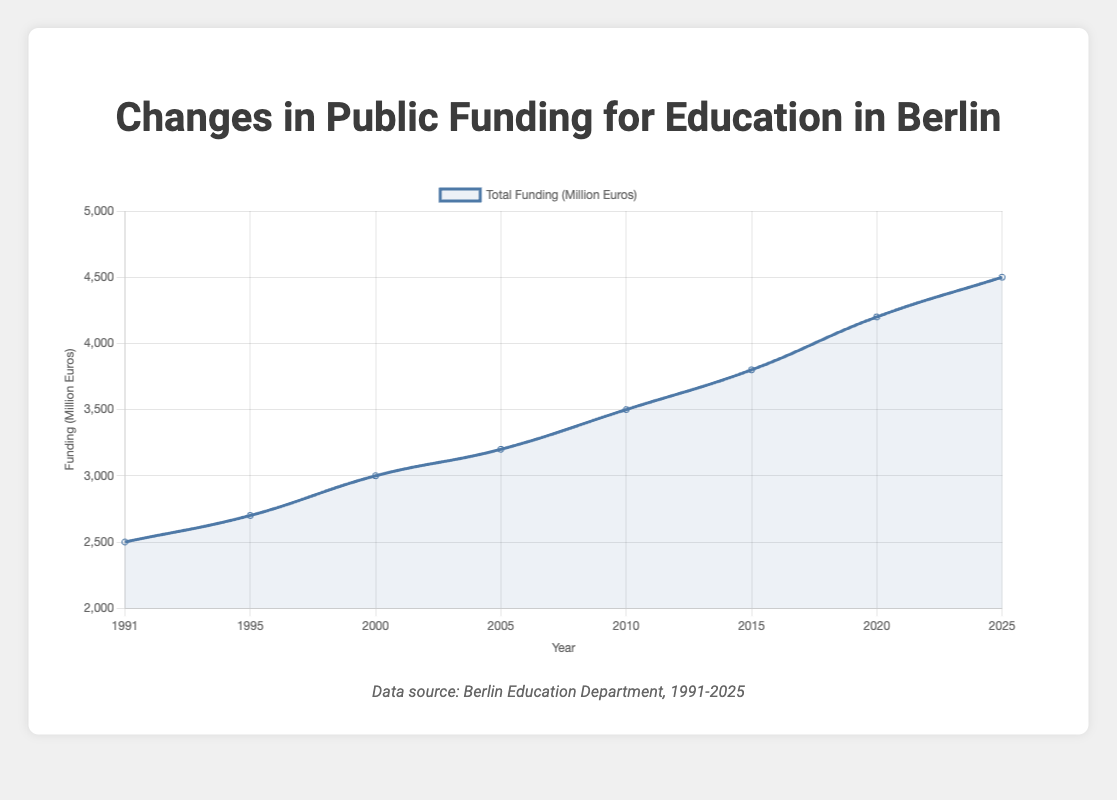What's the general trend of public funding for education in Berlin from 1991 to 2025? The general trend is an increase. Starting from 2500 million euros in 1991, funding rises consistently over the years, reaching 4500 million euros in 2025.
Answer: Increasing How much did the funding increase from 1991 to 2000? The funding in 1991 was 2500 million euros and in 2000 it was 3000 million euros. The difference is 3000 - 2500 = 500 million euros.
Answer: 500 million euros During which government did Berlin see the highest funding in education by 2025? The highest funding is in 2025, which is under the Christian Democratic Union (CDU).
Answer: Christian Democratic Union (CDU) What was the funding in the year 2015, and what policy change was implemented that year? In 2015, the funding was 3800 million euros and the policy change was "Increase in Teacher Salaries".
Answer: 3800 million euros and "Increase in Teacher Salaries" Between which two consecutive years did the funding see the steepest increase? The steepest increase is between 2015 and 2020 where the funding increased from 3800 million euros to 4200 million euros. The difference is 4200 - 3800 = 400 million euros.
Answer: 2015 to 2020 What is the average funding from 1991 to 2025? To find the average, sum all funding values: 2500 + 2700 + 3000 + 3200 + 3500 + 3800 + 4200 + 4500 = 27400 million euros. There are 8 years, so: 27400 / 8 = 3425 million euros.
Answer: 3425 million euros Which policy change occurred when the funding reached 3500 million euros? In 2010, the funding was 3500 million euros and the policy change was "Emphasis on STEM Education".
Answer: "Emphasis on STEM Education" Compare the funding amount in 1995 and 2020. By how much did it increase? The funding in 1995 was 2700 million euros and in 2020 it was 4200 million euros. The increase is 4200 - 2700 = 1500 million euros.
Answer: 1500 million euros What is the median value of the funding amounts from 1991 to 2025? Arrange the funding values in ascending order: 2500, 2700, 3000, 3200, 3500, 3800, 4200, 4500. The median is the average of the 4th and 5th values: (3200 + 3500) / 2 = 3350 million euros.
Answer: 3350 million euros In which year did the SPD-Left Party-Green Coalition first gain power, and what was the associated funding? The SPD-Left Party-Green Coalition first gained power in 2015, with the funding being 3800 million euros.
Answer: 2015 and 3800 million euros 